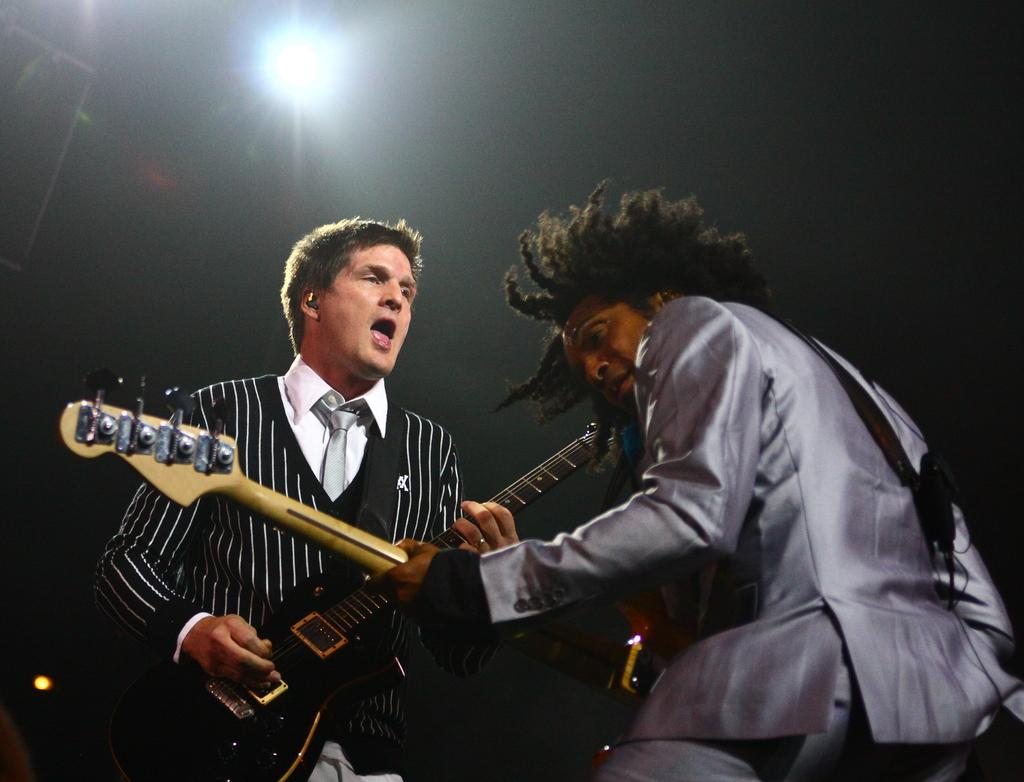How many people are in the image? There are two men in the image. What are the men doing in the image? The men are playing guitars. What type of bun is the men using to play the guitars? There is no bun present in the image; the men are using guitars to play music. 